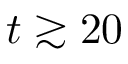<formula> <loc_0><loc_0><loc_500><loc_500>t \gtrsim 2 0</formula> 